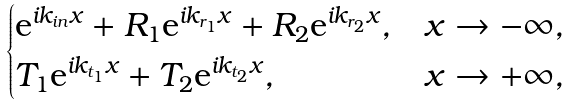<formula> <loc_0><loc_0><loc_500><loc_500>\begin{cases} \text {e} ^ { i k _ { i n } x } + R _ { 1 } \text {e} ^ { i k _ { r _ { 1 } } x } + R _ { 2 } \text {e} ^ { i k _ { r _ { 2 } } x } , & x \rightarrow - \infty , \\ T _ { 1 } \text {e} ^ { i k _ { t _ { 1 } } x } + T _ { 2 } \text {e} ^ { i k _ { t _ { 2 } } x } , & x \rightarrow + \infty , \end{cases}</formula> 